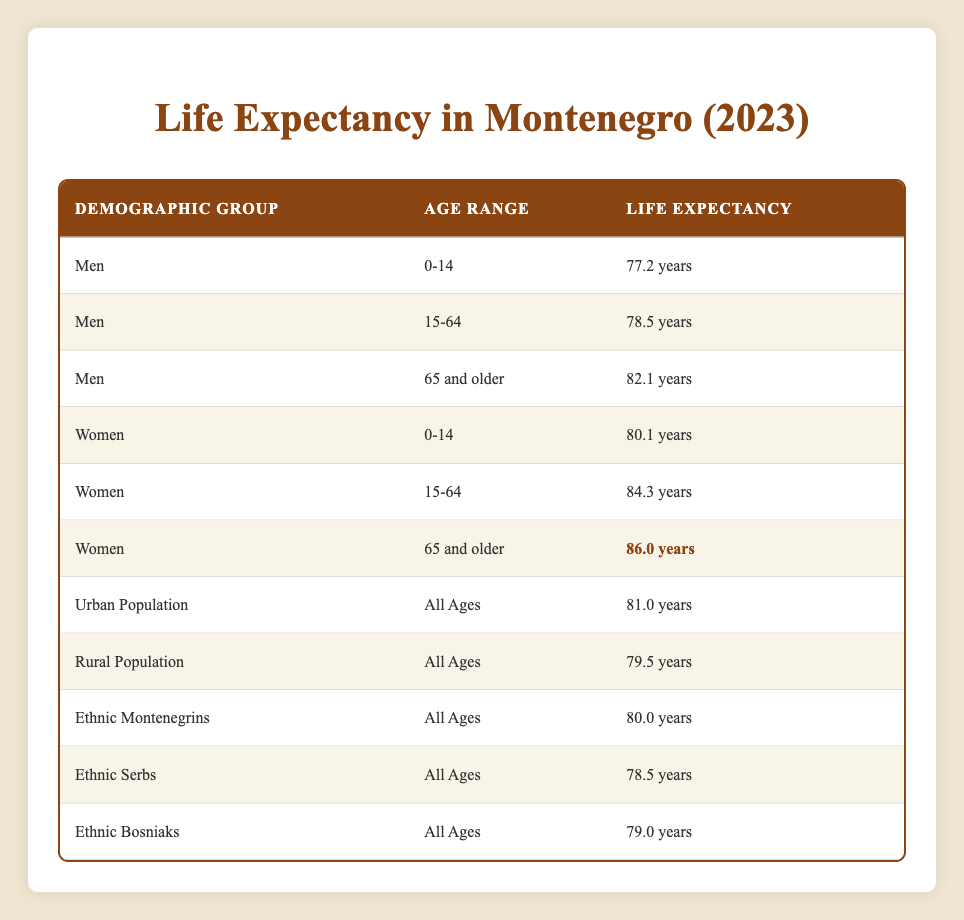What is the life expectancy of women aged 65 and older in Montenegro? The table explicitly lists the life expectancy for women in the age range of 65 and older as 86.0 years.
Answer: 86.0 years What is the difference in life expectancy between urban and rural populations? According to the table, the life expectancy for the urban population is 81.0 years and for the rural population, it is 79.5 years. The difference is 81.0 - 79.5 = 1.5 years.
Answer: 1.5 years Is the life expectancy for ethnic Serbs higher than for ethnic Bosniaks? The life expectancy for ethnic Serbs is 78.5 years, while for ethnic Bosniaks, it is 79.0 years. Since 78.5 is less than 79.0, the statement is false.
Answer: No What is the average life expectancy for men across all age ranges? The life expectancies for men in different age ranges are 77.2 (0-14), 78.5 (15-64), and 82.1 (65 and older). To find the average, we add these values: 77.2 + 78.5 + 82.1 = 237.8, and then divide by 3 (the number of values): 237.8 / 3 ≈ 79.27.
Answer: Approximately 79.27 years Which demographic group has the highest life expectancy? Looking at all the groups listed, women aged 65 and older have the highest life expectancy at 86.0 years, as indicated in the table.
Answer: Women aged 65 and older (86.0 years) 